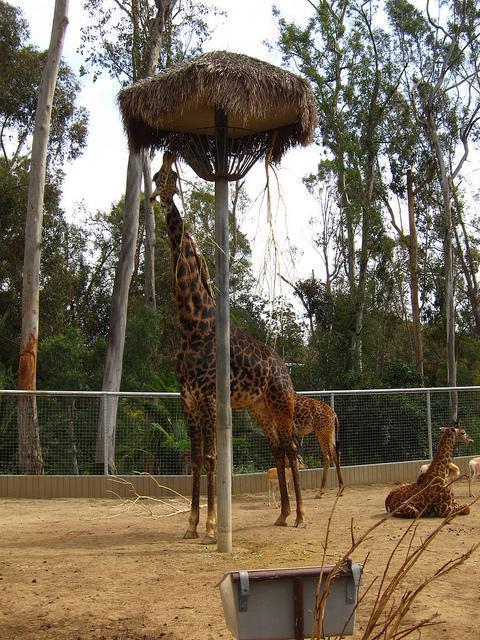How many animals are here?
Give a very brief answer. 3. How many giraffes are there?
Give a very brief answer. 3. How many yellow bikes are there?
Give a very brief answer. 0. 